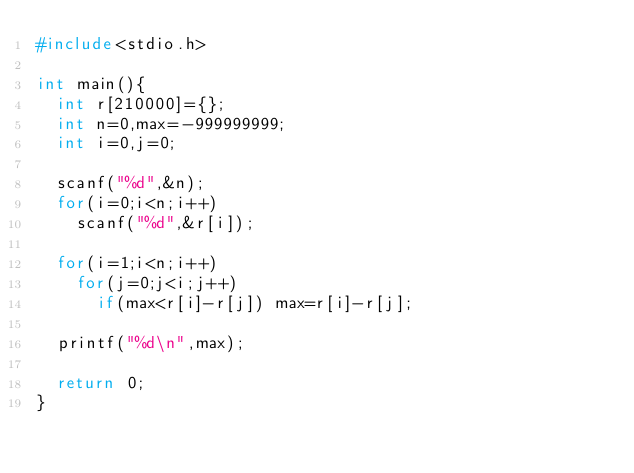<code> <loc_0><loc_0><loc_500><loc_500><_C_>#include<stdio.h>

int main(){
  int r[210000]={};
  int n=0,max=-999999999;
  int i=0,j=0;

  scanf("%d",&n);
  for(i=0;i<n;i++)
    scanf("%d",&r[i]);

  for(i=1;i<n;i++)
    for(j=0;j<i;j++)
      if(max<r[i]-r[j]) max=r[i]-r[j];

  printf("%d\n",max);
  
  return 0;
}

</code> 